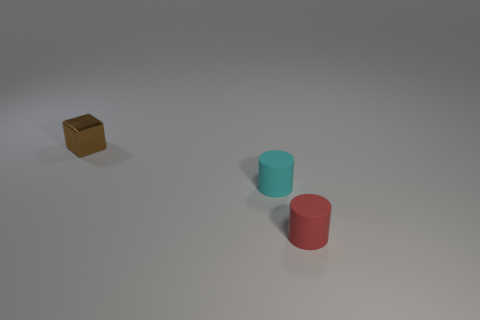Add 1 blocks. How many objects exist? 4 Subtract all blocks. How many objects are left? 2 Add 1 brown objects. How many brown objects exist? 2 Subtract 0 gray spheres. How many objects are left? 3 Subtract all large gray rubber spheres. Subtract all red things. How many objects are left? 2 Add 1 cyan matte cylinders. How many cyan matte cylinders are left? 2 